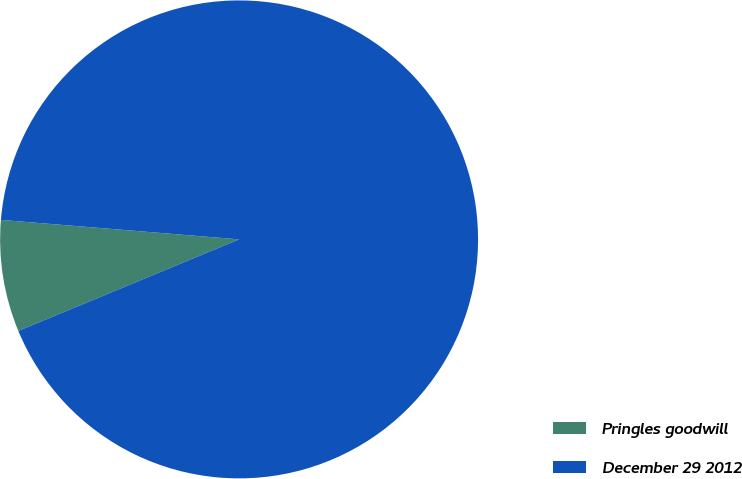<chart> <loc_0><loc_0><loc_500><loc_500><pie_chart><fcel>Pringles goodwill<fcel>December 29 2012<nl><fcel>7.56%<fcel>92.44%<nl></chart> 